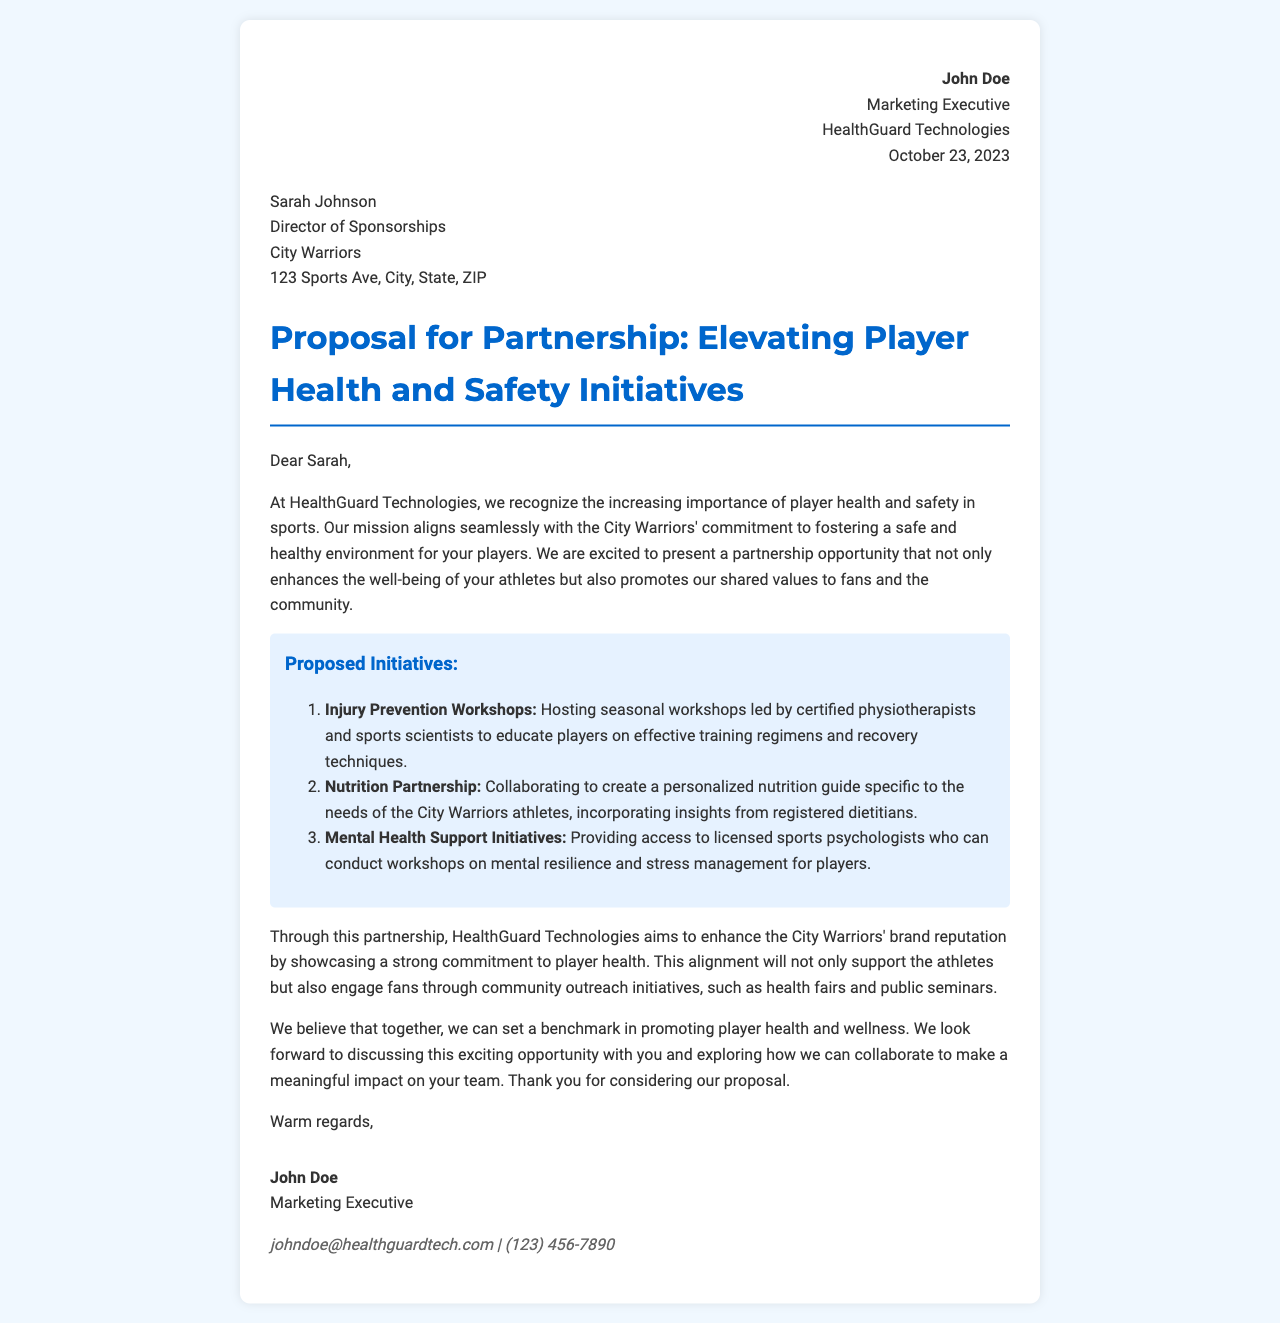What is the date of the letter? The date in the letter is stated in the header section as October 23, 2023.
Answer: October 23, 2023 Who is the sender of the letter? The sender's name is mentioned at the top of the letter as John Doe.
Answer: John Doe What is the proposed initiative related to nutrition? The proposal includes creating a personalized nutrition guide specific to the needs of the City Warriors athletes.
Answer: Nutrition Partnership How many proposed initiatives are listed? The document outlines three initiatives in the proposed initiatives section.
Answer: Three What is the primary mission of HealthGuard Technologies as mentioned in the letter? The letter states that the mission of HealthGuard Technologies aligns with fostering a safe and healthy environment for players.
Answer: Player health and safety What role does Sarah Johnson hold? The recipient section specifies that Sarah Johnson is the Director of Sponsorships.
Answer: Director of Sponsorships Which organization is seeking a partnership? The letter is from HealthGuard Technologies, which is seeking the partnership.
Answer: HealthGuard Technologies What is the email address of the sender? The sender's contact details include the email johndoe@healthguardtech.com.
Answer: johndoe@healthguardtech.com What type of workshops does the first initiative propose? The first initiative proposes hosting seasonal workshops led by certified physiotherapists.
Answer: Injury Prevention Workshops 